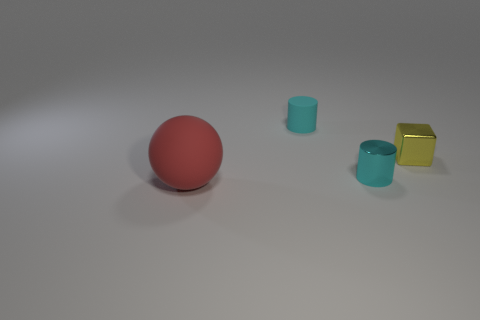What is the color of the thing that is to the left of the rubber thing behind the metal cylinder?
Your response must be concise. Red. Are the large red object and the thing that is behind the tiny yellow shiny block made of the same material?
Provide a short and direct response. Yes. There is a tiny cube right of the tiny cylinder in front of the rubber thing right of the large red object; what is its color?
Make the answer very short. Yellow. Are there any other things that are the same shape as the small rubber object?
Give a very brief answer. Yes. Is the number of large spheres greater than the number of green blocks?
Your answer should be very brief. Yes. What number of things are both in front of the tiny matte thing and to the left of the small cube?
Ensure brevity in your answer.  2. How many small shiny blocks are in front of the cylinder in front of the tiny metallic cube?
Give a very brief answer. 0. There is a cylinder in front of the matte cylinder; is it the same size as the cyan cylinder behind the cyan shiny cylinder?
Your response must be concise. Yes. What number of metal things are there?
Give a very brief answer. 2. What number of red objects have the same material as the block?
Offer a very short reply. 0. 